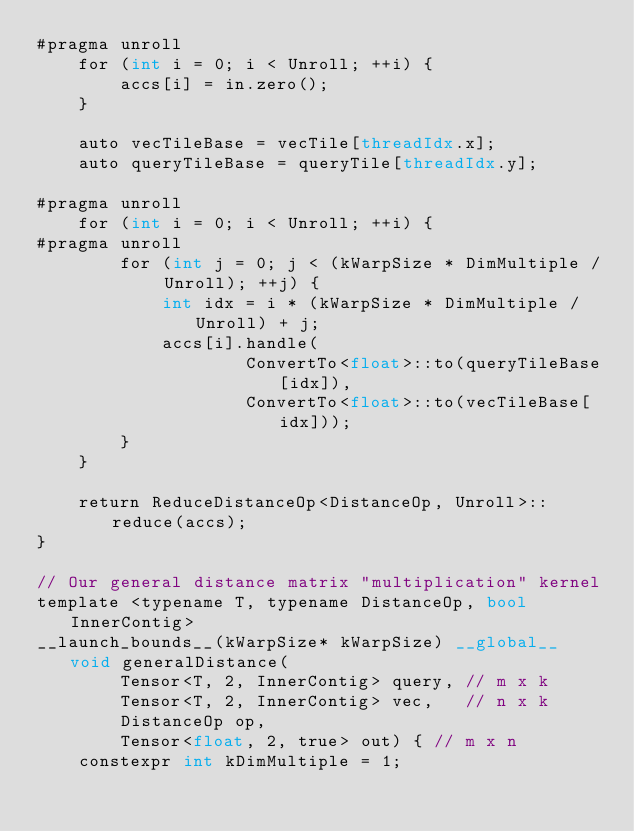<code> <loc_0><loc_0><loc_500><loc_500><_Cuda_>#pragma unroll
    for (int i = 0; i < Unroll; ++i) {
        accs[i] = in.zero();
    }

    auto vecTileBase = vecTile[threadIdx.x];
    auto queryTileBase = queryTile[threadIdx.y];

#pragma unroll
    for (int i = 0; i < Unroll; ++i) {
#pragma unroll
        for (int j = 0; j < (kWarpSize * DimMultiple / Unroll); ++j) {
            int idx = i * (kWarpSize * DimMultiple / Unroll) + j;
            accs[i].handle(
                    ConvertTo<float>::to(queryTileBase[idx]),
                    ConvertTo<float>::to(vecTileBase[idx]));
        }
    }

    return ReduceDistanceOp<DistanceOp, Unroll>::reduce(accs);
}

// Our general distance matrix "multiplication" kernel
template <typename T, typename DistanceOp, bool InnerContig>
__launch_bounds__(kWarpSize* kWarpSize) __global__ void generalDistance(
        Tensor<T, 2, InnerContig> query, // m x k
        Tensor<T, 2, InnerContig> vec,   // n x k
        DistanceOp op,
        Tensor<float, 2, true> out) { // m x n
    constexpr int kDimMultiple = 1;
</code> 